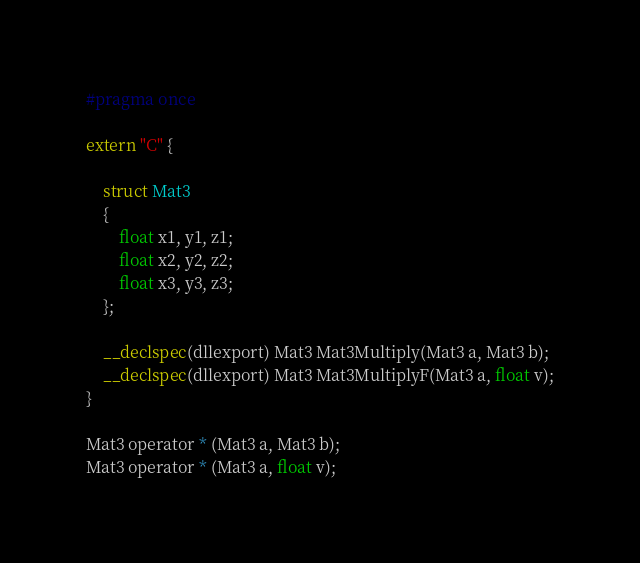Convert code to text. <code><loc_0><loc_0><loc_500><loc_500><_C_>#pragma once

extern "C" {

	struct Mat3
	{
		float x1, y1, z1;
		float x2, y2, z2;
		float x3, y3, z3;
	};

	__declspec(dllexport) Mat3 Mat3Multiply(Mat3 a, Mat3 b);
	__declspec(dllexport) Mat3 Mat3MultiplyF(Mat3 a, float v);
}

Mat3 operator * (Mat3 a, Mat3 b);
Mat3 operator * (Mat3 a, float v);</code> 